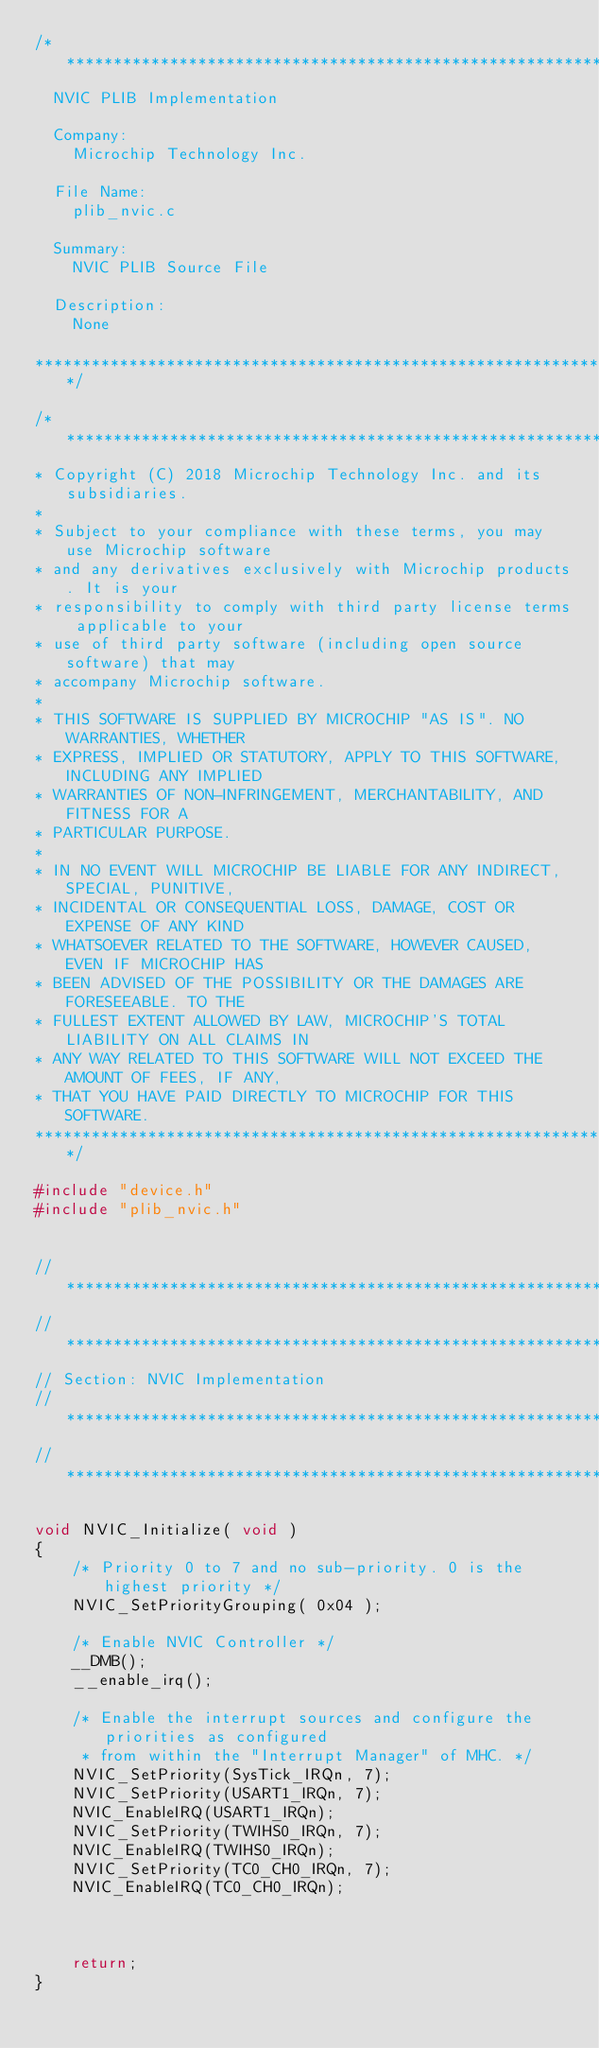Convert code to text. <code><loc_0><loc_0><loc_500><loc_500><_C_>/*******************************************************************************
  NVIC PLIB Implementation

  Company:
    Microchip Technology Inc.

  File Name:
    plib_nvic.c

  Summary:
    NVIC PLIB Source File

  Description:
    None

*******************************************************************************/

/*******************************************************************************
* Copyright (C) 2018 Microchip Technology Inc. and its subsidiaries.
*
* Subject to your compliance with these terms, you may use Microchip software
* and any derivatives exclusively with Microchip products. It is your
* responsibility to comply with third party license terms applicable to your
* use of third party software (including open source software) that may
* accompany Microchip software.
*
* THIS SOFTWARE IS SUPPLIED BY MICROCHIP "AS IS". NO WARRANTIES, WHETHER
* EXPRESS, IMPLIED OR STATUTORY, APPLY TO THIS SOFTWARE, INCLUDING ANY IMPLIED
* WARRANTIES OF NON-INFRINGEMENT, MERCHANTABILITY, AND FITNESS FOR A
* PARTICULAR PURPOSE.
*
* IN NO EVENT WILL MICROCHIP BE LIABLE FOR ANY INDIRECT, SPECIAL, PUNITIVE,
* INCIDENTAL OR CONSEQUENTIAL LOSS, DAMAGE, COST OR EXPENSE OF ANY KIND
* WHATSOEVER RELATED TO THE SOFTWARE, HOWEVER CAUSED, EVEN IF MICROCHIP HAS
* BEEN ADVISED OF THE POSSIBILITY OR THE DAMAGES ARE FORESEEABLE. TO THE
* FULLEST EXTENT ALLOWED BY LAW, MICROCHIP'S TOTAL LIABILITY ON ALL CLAIMS IN
* ANY WAY RELATED TO THIS SOFTWARE WILL NOT EXCEED THE AMOUNT OF FEES, IF ANY,
* THAT YOU HAVE PAID DIRECTLY TO MICROCHIP FOR THIS SOFTWARE.
*******************************************************************************/

#include "device.h"
#include "plib_nvic.h"


// *****************************************************************************
// *****************************************************************************
// Section: NVIC Implementation
// *****************************************************************************
// *****************************************************************************

void NVIC_Initialize( void )
{
    /* Priority 0 to 7 and no sub-priority. 0 is the highest priority */
    NVIC_SetPriorityGrouping( 0x04 );

    /* Enable NVIC Controller */
    __DMB();
    __enable_irq();

    /* Enable the interrupt sources and configure the priorities as configured
     * from within the "Interrupt Manager" of MHC. */
    NVIC_SetPriority(SysTick_IRQn, 7);
    NVIC_SetPriority(USART1_IRQn, 7);
    NVIC_EnableIRQ(USART1_IRQn);
    NVIC_SetPriority(TWIHS0_IRQn, 7);
    NVIC_EnableIRQ(TWIHS0_IRQn);
    NVIC_SetPriority(TC0_CH0_IRQn, 7);
    NVIC_EnableIRQ(TC0_CH0_IRQn);



    return;
}
</code> 